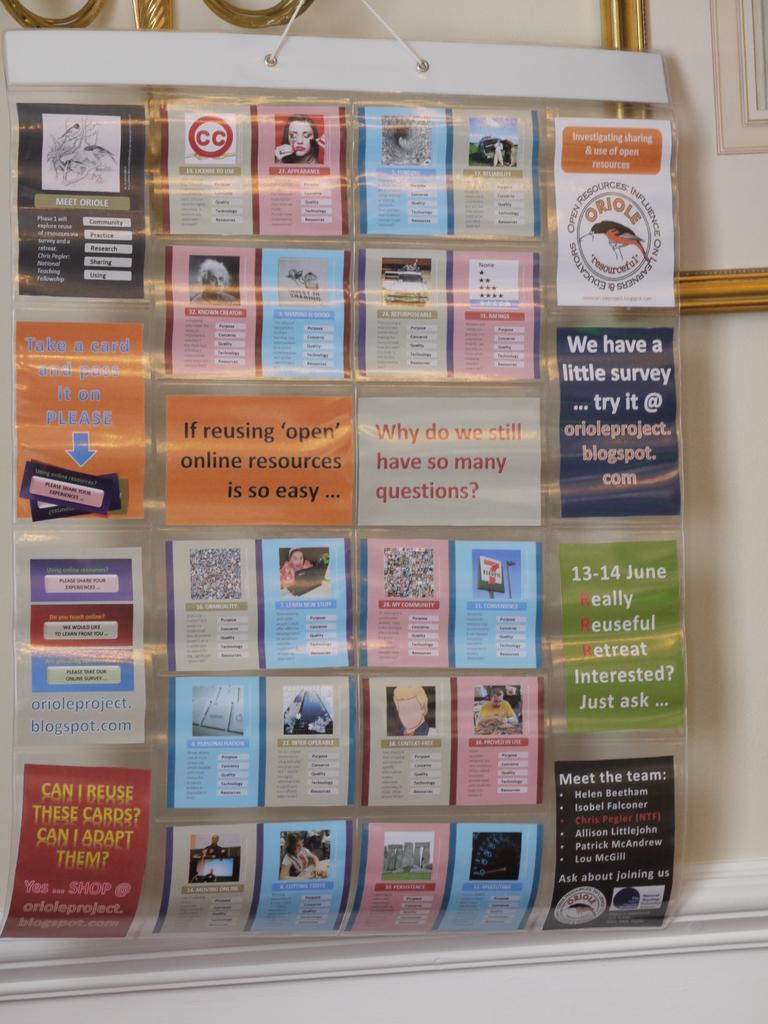<image>
Render a clear and concise summary of the photo. A display board has information about online resources. 